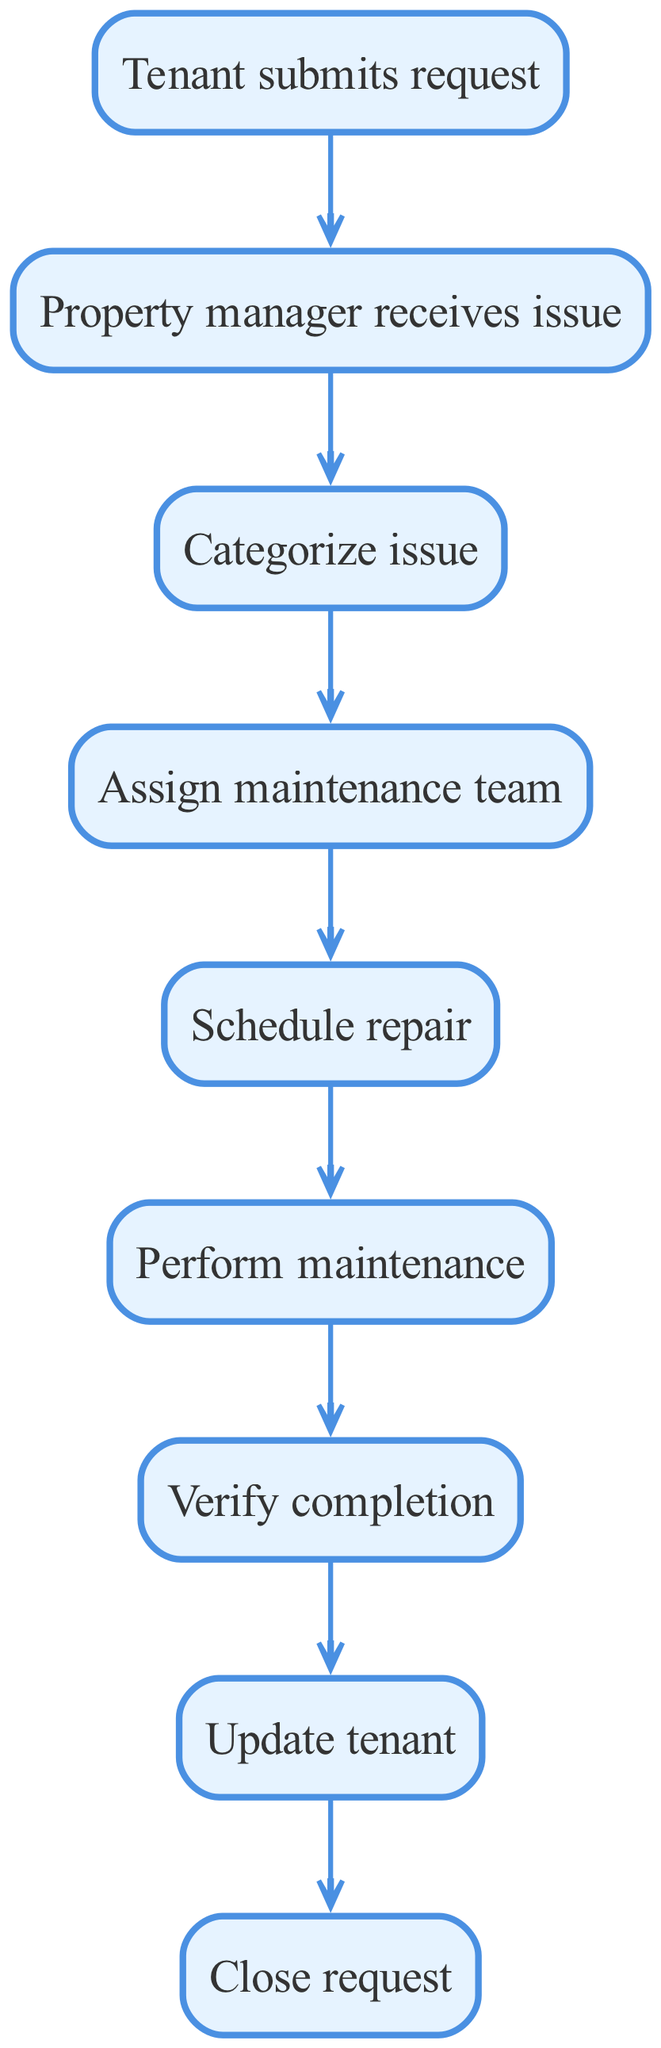What is the first step in the property management workflow? The first step is when the "Tenant submits request," indicating the initiation of the process by the tenant reporting an issue.
Answer: Tenant submits request How many nodes are present in the diagram? By counting the individual steps listed as nodes, we find that there are eight distinct nodes that represent the stages of the workflow.
Answer: 8 What is the node that follows "Schedule repair"? According to the flow, the node directly following "Schedule repair" is "Perform maintenance," which comes next in the process of addressing tenant issues.
Answer: Perform maintenance Which node serves as the final step in the workflow? The last action outlined in the diagram is "Close request," which indicates the completion of the process after all preceding steps are finalized.
Answer: Close request What action comes after verifying the completion of maintenance? After "Verify completion," the next step is "Update tenant," which entails informing the tenant about the status and outcome of their request.
Answer: Update tenant If a tenant submits a request, which node is next in the workflow? Following the tenant's submission of a request, the next node in the workflow is "Property manager receives issue," where the property manager first learns of the tenant's concern.
Answer: Property manager receives issue How many edges connect the nodes in the graph? By examining the connections or the relationships between the nodes, we see there are eight edges representing the flow between each step in the process.
Answer: 8 Which two nodes directly connect the "Categorize issue" node? The "Categorize issue" node is directly connected to "Property manager receives issue" (before) and "Assign maintenance team" (after), showing its position within the workflow.
Answer: Property manager receives issue, Assign maintenance team What role does the "Assign maintenance team" node play in the workflow? The "Assign maintenance team" node's role is to designate the appropriate maintenance team to address the categorized issue, reflecting a crucial step in the repair process.
Answer: Assign maintenance team 